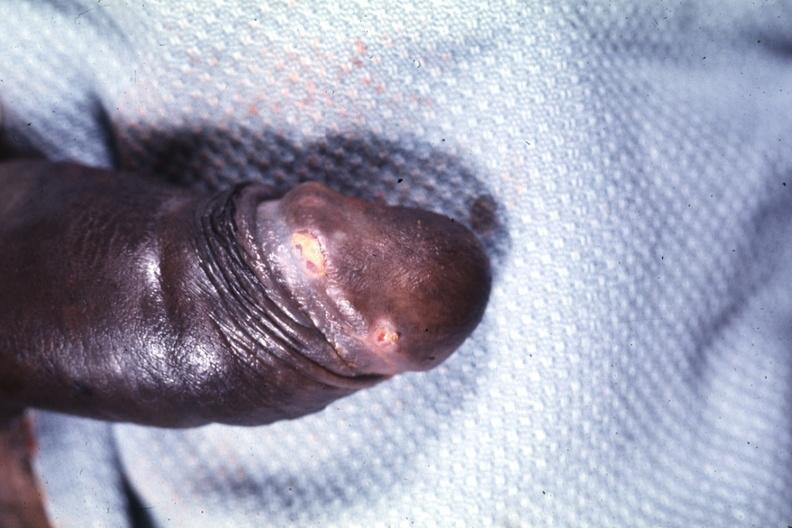s penis present?
Answer the question using a single word or phrase. Yes 